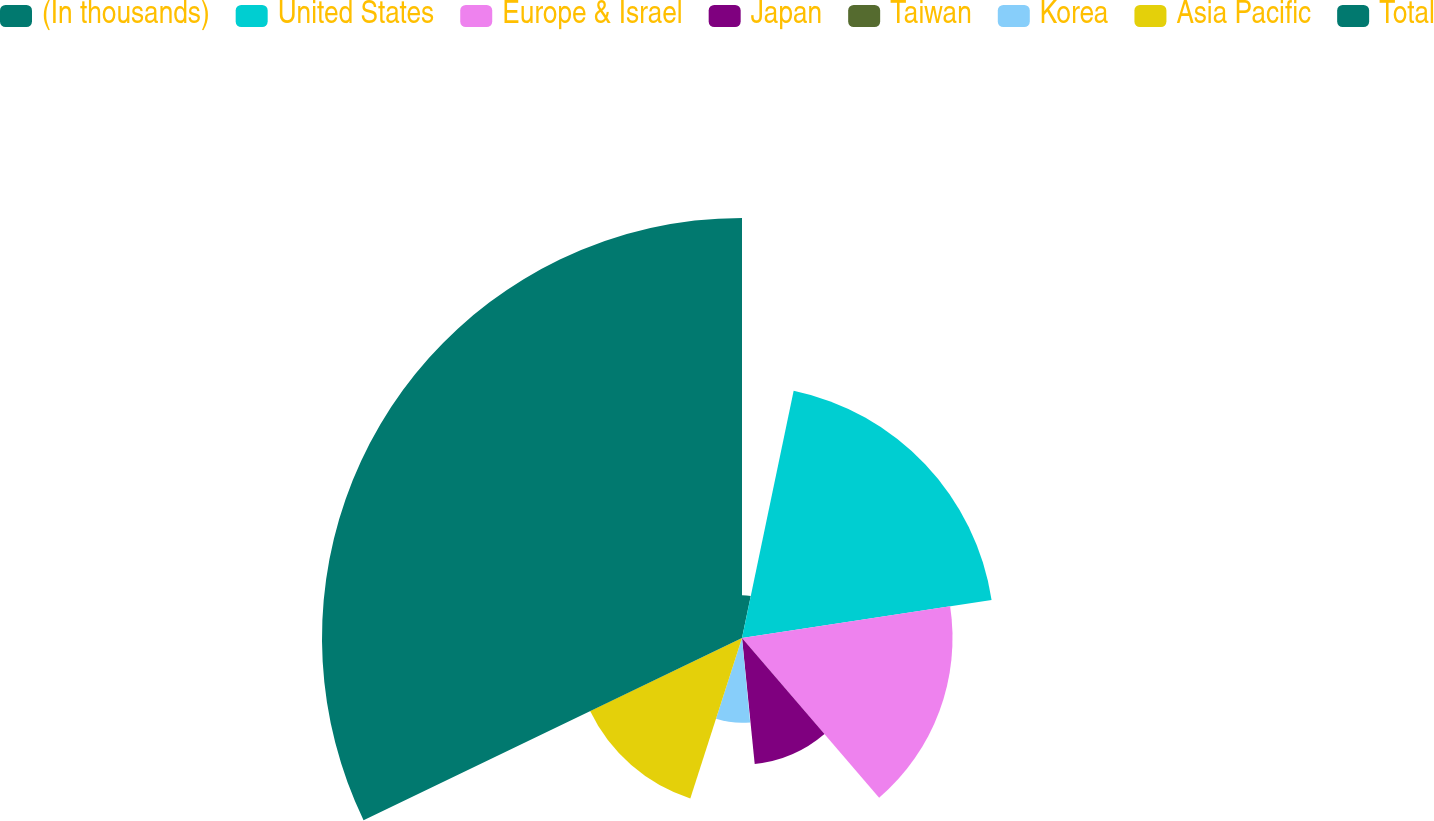<chart> <loc_0><loc_0><loc_500><loc_500><pie_chart><fcel>(In thousands)<fcel>United States<fcel>Europe & Israel<fcel>Japan<fcel>Taiwan<fcel>Korea<fcel>Asia Pacific<fcel>Total<nl><fcel>3.28%<fcel>19.32%<fcel>16.11%<fcel>9.69%<fcel>0.07%<fcel>6.49%<fcel>12.9%<fcel>32.14%<nl></chart> 